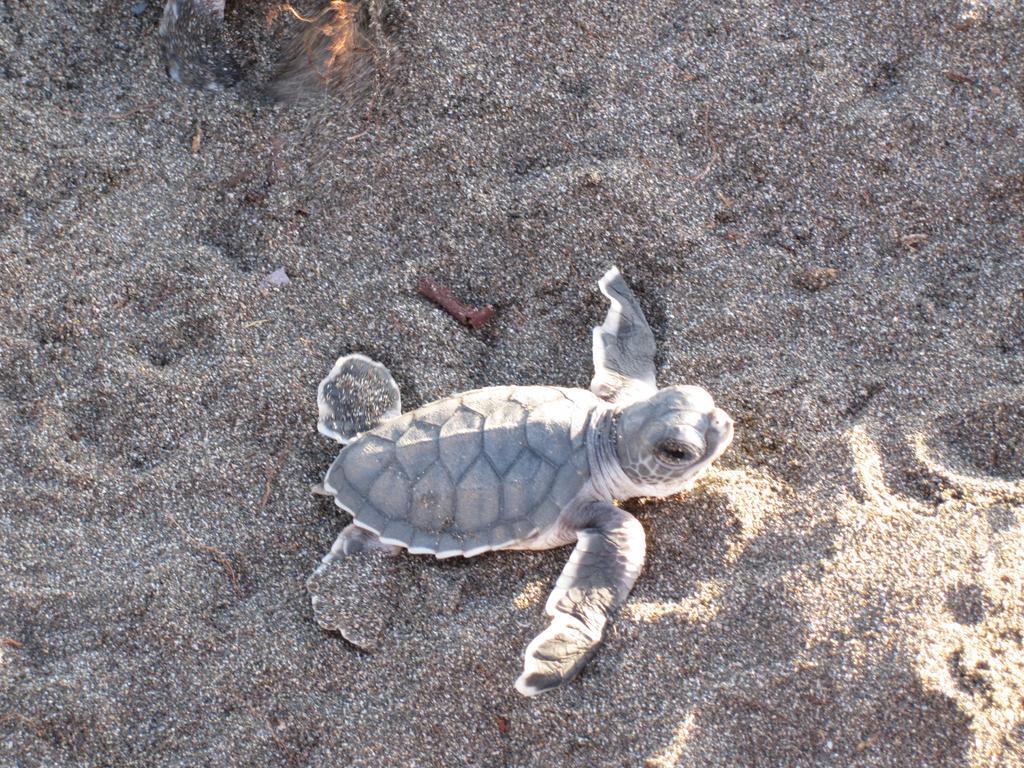In one or two sentences, can you explain what this image depicts? In this picture we can see a turtle on the sand. 